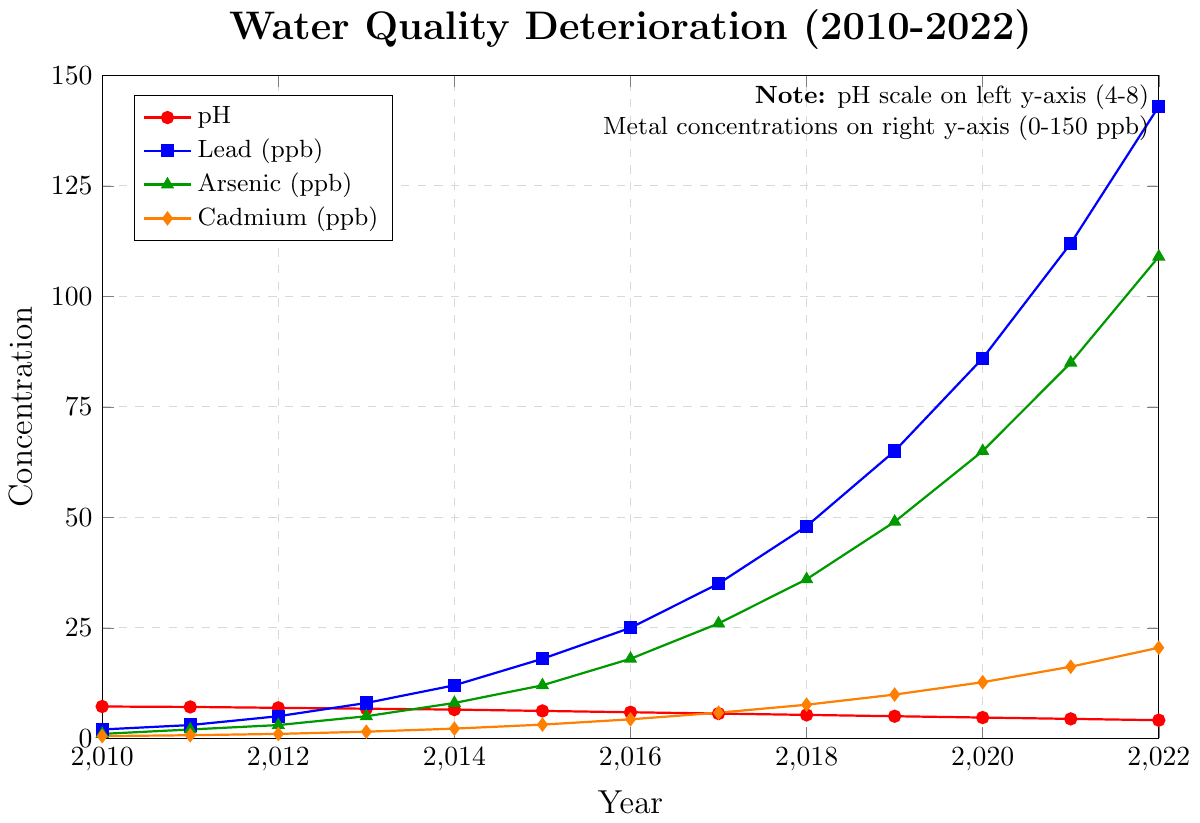What's the trend in pH levels from 2010 to 2022? The pH levels consistently decrease from 7.2 in 2010 to 4.1 in 2022, indicating an increase in acidity over the years.
Answer: Decreasing trend Which year did lead concentration see the largest increase compared to the previous year? From 2011 to 2012, lead concentration increased by 2 ppb (3 vs. 5), from 2012 to 2013 by 3 ppb (5 vs. 8), and so on. The biggest jump is from 2021 to 2022, where lead concentration increased by 31 ppb (112 vs. 143).
Answer: 2021-2022 What was the pH level in 2015? How does it compare to the pH level in 2010? In 2010, the pH level was 7.2, and in 2015, it was 6.2. The pH level decreased by 1.0 units from 2010 to 2015.
Answer: 6.2; Decreased by 1.0 By what percentage did cadmium concentration increase from 2010 to 2022? In 2010, the cadmium concentration was 0.5 ppb, and in 2022 it was 20.5 ppb. The increase is 20.0 ppb. The percentage increase is (20.0/0.5) * 100% = 4000%.
Answer: 4000% Between which two consecutive years did arsenic concentration experience its smallest increase? By examining the yearly increases: (2010-2011) 1 ppb, (2011-2012) 1 ppb, (2012-2013) 2 ppb, (2013-2014) 3 ppb, and so on. The smallest increases are between 2010 and 2011, and between 2011 and 2012, both being 1 ppb.
Answer: 2010-2011 and 2011-2012 How did lead concentrations in 2016 compare to those in 2015? In 2015, the lead concentration was 18 ppb, while in 2016 it was 25 ppb, indicating an increase of 7 ppb.
Answer: Increased by 7 ppb Which year showed the most rapid decline in pH level? The pH levels for each year show a relatively uniform decline, but the largest year-to-year decrease was from 2019 to 2020, dropping from 5.0 to 4.7 (a decrease of 0.3).
Answer: 2019-2020 What is the combined concentration of arsenic and cadmium in 2018? In 2018, the concentration of arsenic was 36 ppb and cadmium was 7.6 ppb. Their combined concentration is 36 + 7.6 = 43.6 ppb.
Answer: 43.6 ppb Which element (Lead, Arsenic, Cadmium) experienced the highest concentration increase from 2010 to 2022? Lead increased from 2 ppb to 143 ppb (an increase of 141 ppb), Arsenic from 1 ppb to 109 ppb (an increase of 108 ppb), and Cadmium from 0.5 ppb to 20.5 ppb (an increase of 20 ppb). The highest increase is observed in Lead.
Answer: Lead Compare the consistency of the trend in pH levels and cadmium concentrations over the years. Both pH levels and cadmium concentrations show a consistent trend over the years, with pH levels decreasing steadily and cadmium concentrations increasing steadily each year.
Answer: Consistent for both 